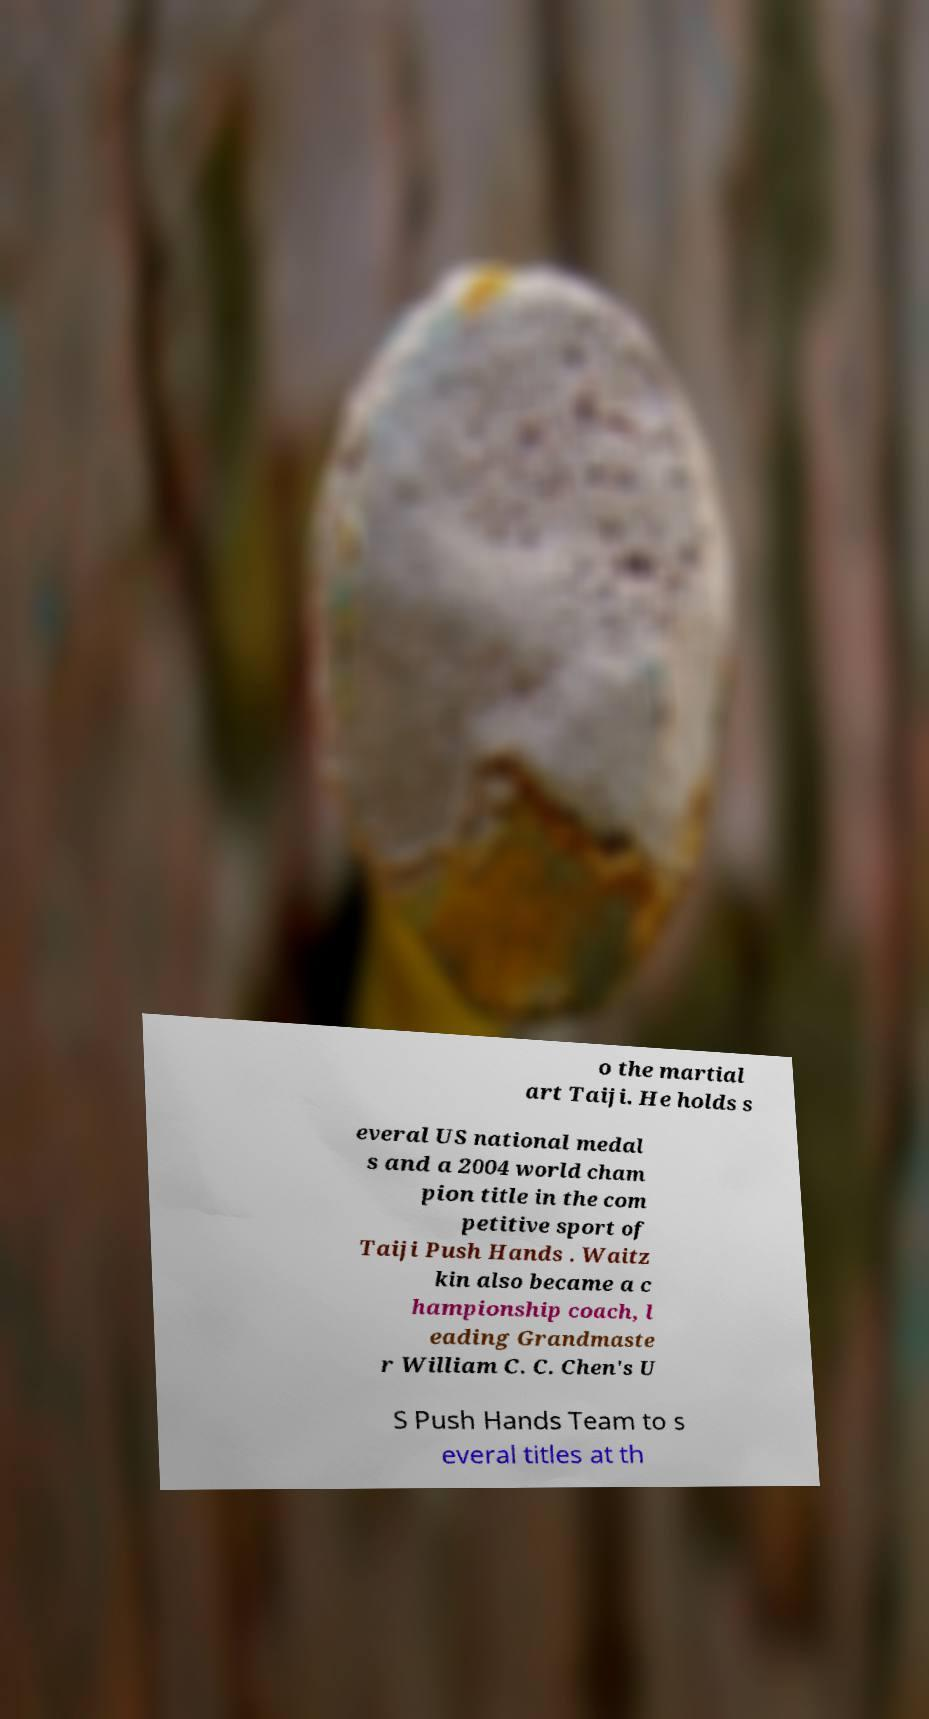Can you accurately transcribe the text from the provided image for me? o the martial art Taiji. He holds s everal US national medal s and a 2004 world cham pion title in the com petitive sport of Taiji Push Hands . Waitz kin also became a c hampionship coach, l eading Grandmaste r William C. C. Chen's U S Push Hands Team to s everal titles at th 